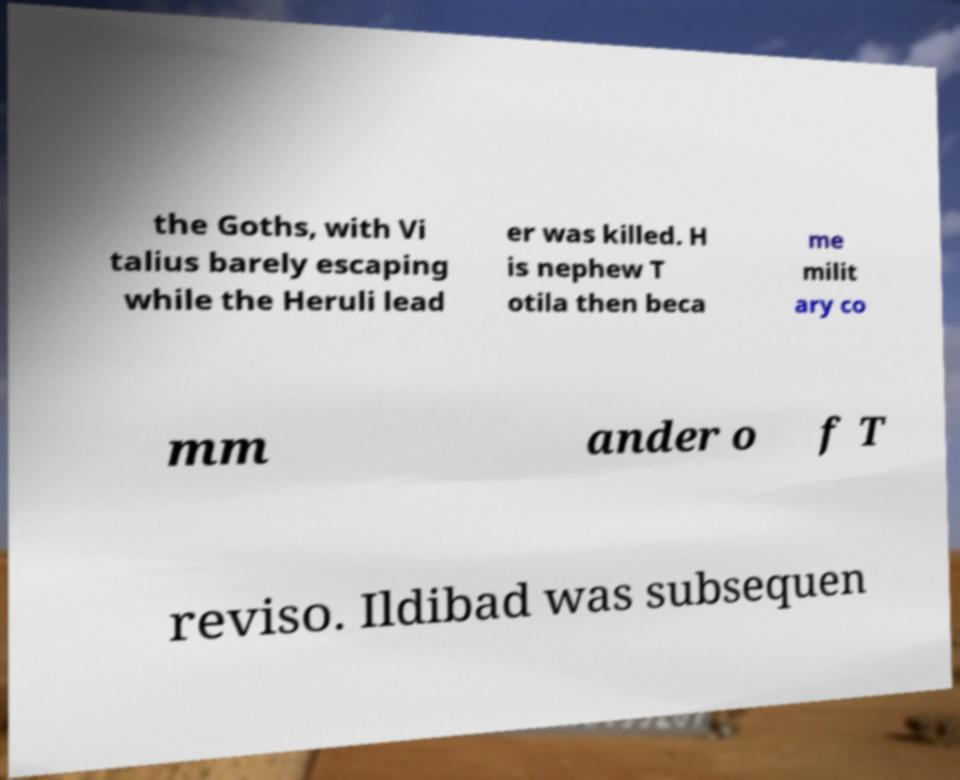Can you accurately transcribe the text from the provided image for me? the Goths, with Vi talius barely escaping while the Heruli lead er was killed. H is nephew T otila then beca me milit ary co mm ander o f T reviso. Ildibad was subsequen 